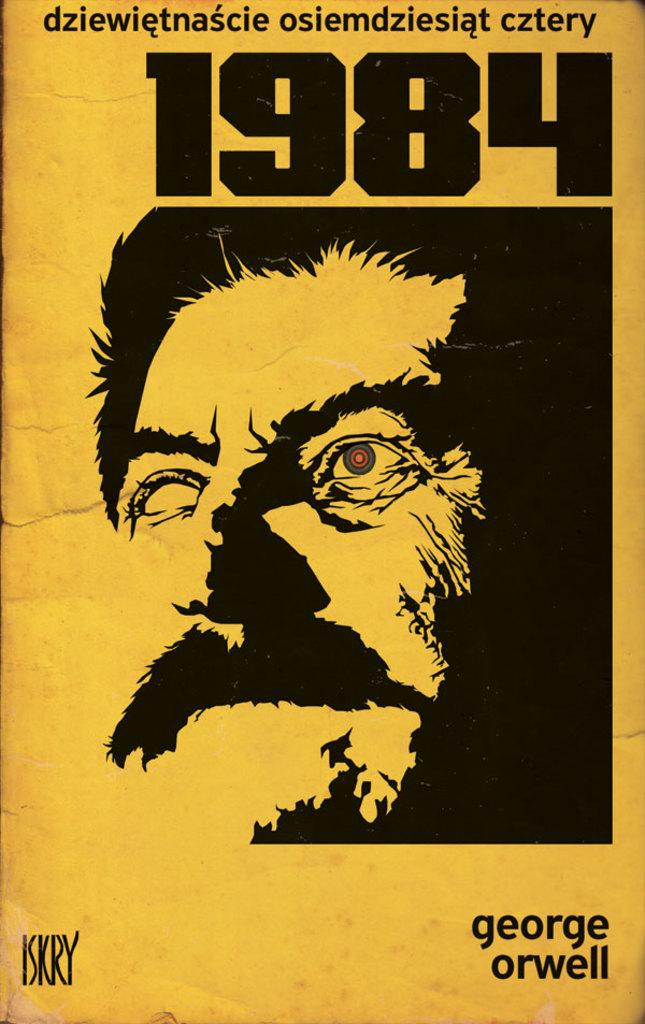Provide a one-sentence caption for the provided image. A German language copy of 1984 by George Orwell. 